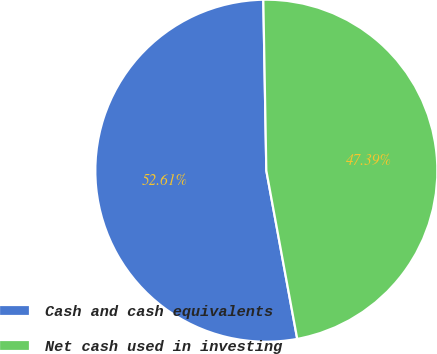<chart> <loc_0><loc_0><loc_500><loc_500><pie_chart><fcel>Cash and cash equivalents<fcel>Net cash used in investing<nl><fcel>52.61%<fcel>47.39%<nl></chart> 